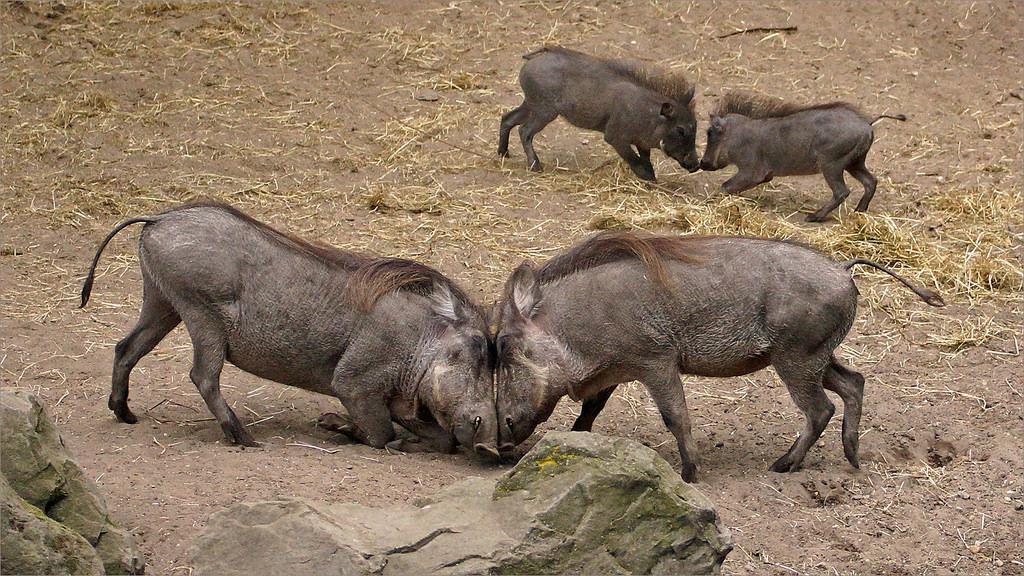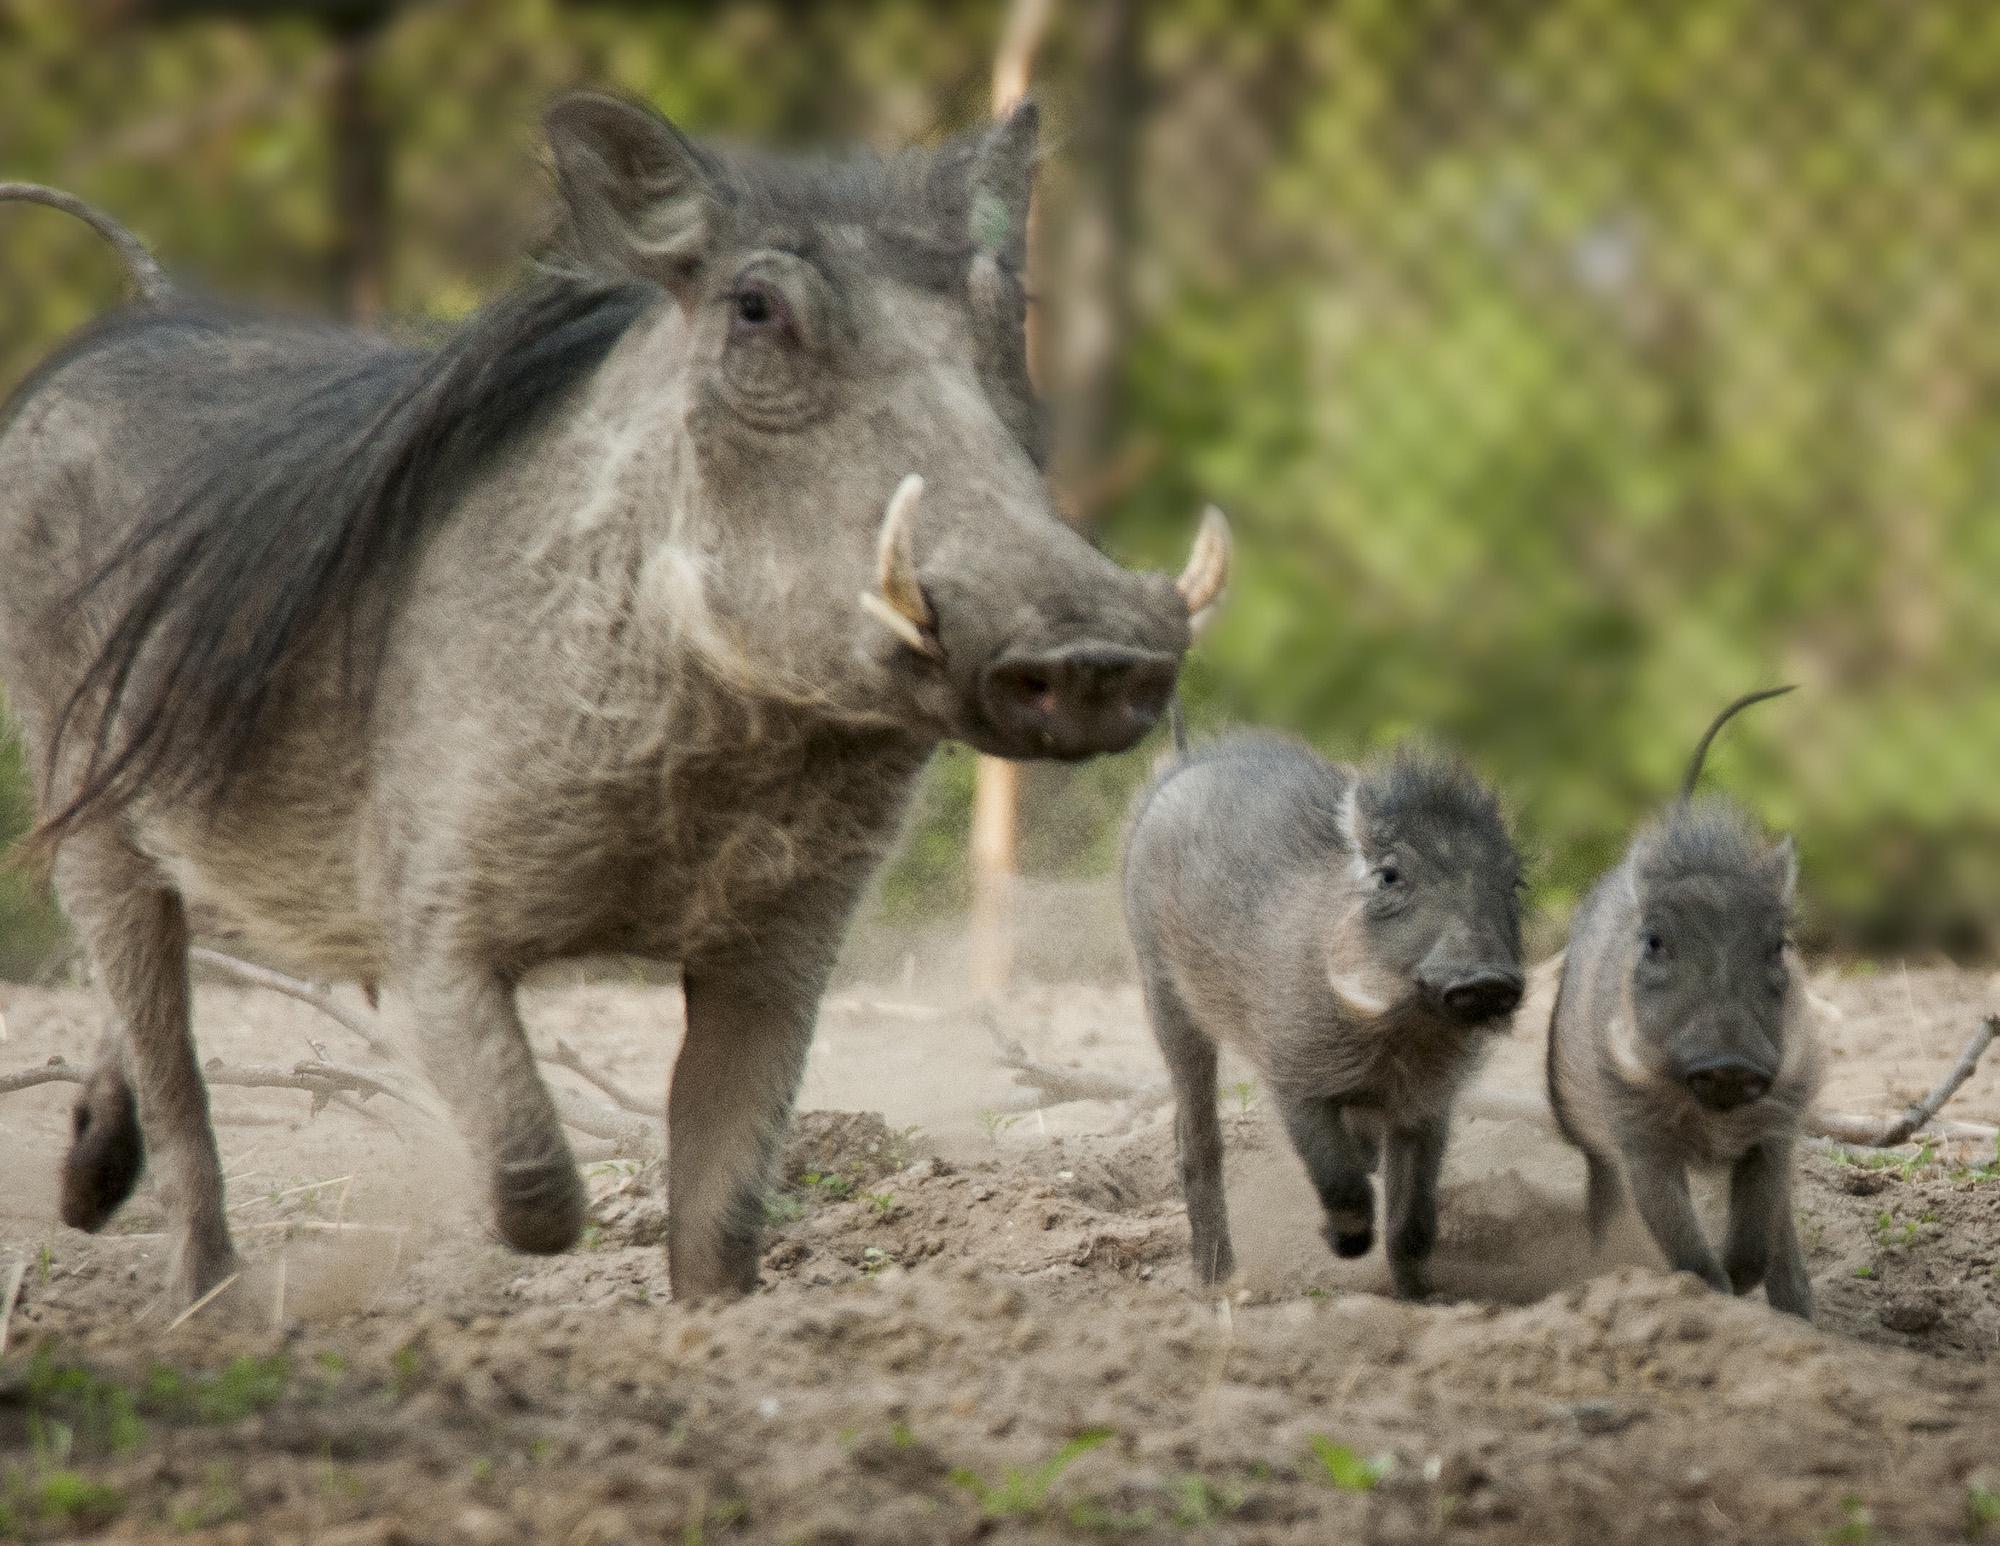The first image is the image on the left, the second image is the image on the right. Evaluate the accuracy of this statement regarding the images: "Two of the animals in the image on the left are butting heads.". Is it true? Answer yes or no. Yes. 